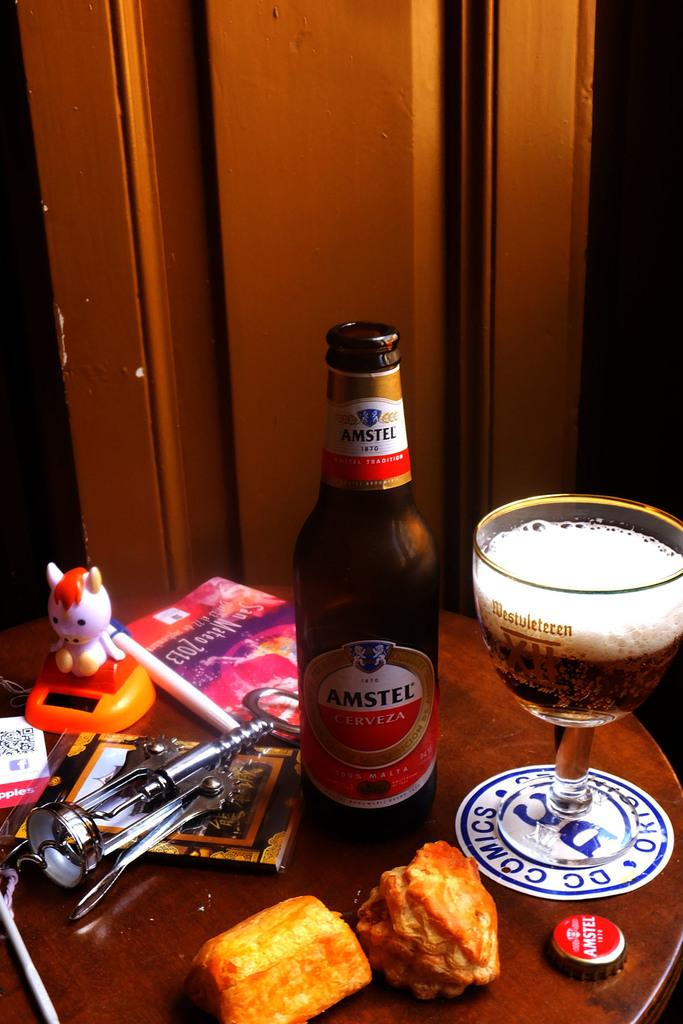<image>
Offer a succinct explanation of the picture presented. A beer called Amestel Cerveza sits on a table. 